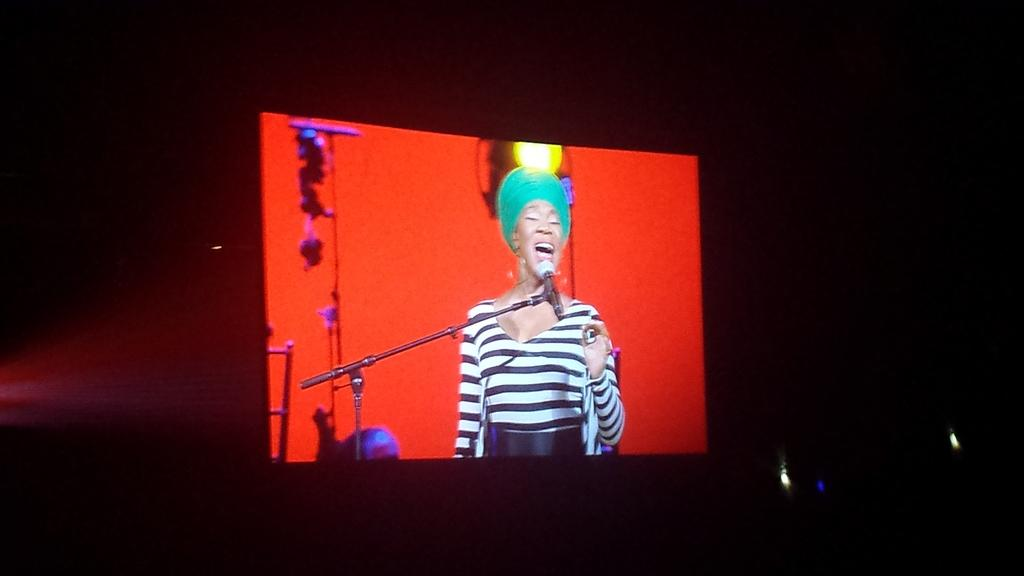What is the main object in the image? There is a screen in the image. What can be seen on the screen? A microphone is present on the screen. Who is standing behind the microphone? A woman is standing behind the microphone. What is the woman doing? The woman is singing. What hobbies does the woman have, as seen in the image? The image does not provide information about the woman's hobbies. Can you tell me the direction the woman is facing in the image? The image does not provide information about the direction the woman is facing. 